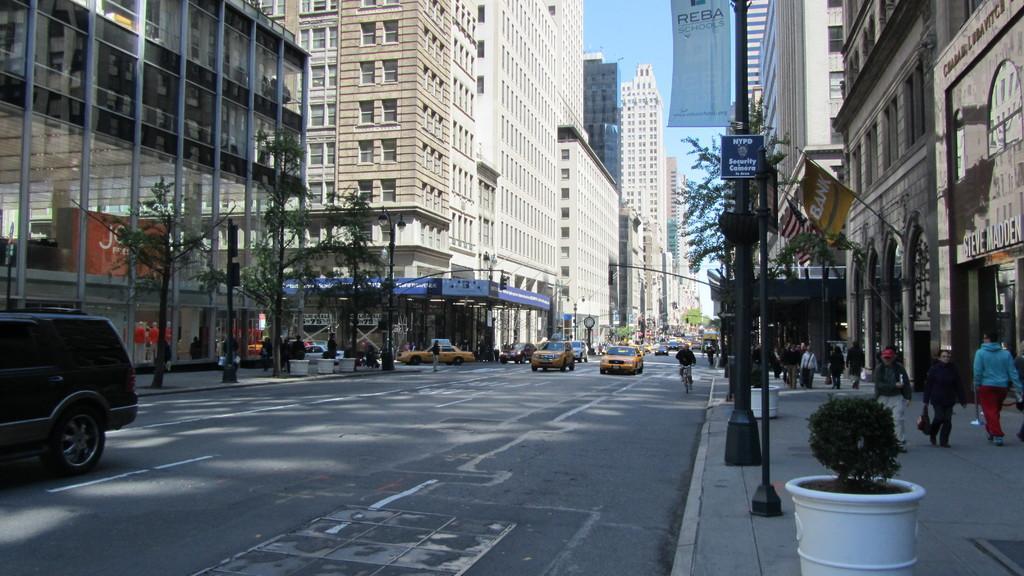How would you summarize this image in a sentence or two? This picture shows few buildings and we see trees and few poles on the sidewalk and we see few vehicles moving on the road and people walking on the sidewalk and we see flags to the building and a cloudy sky. 